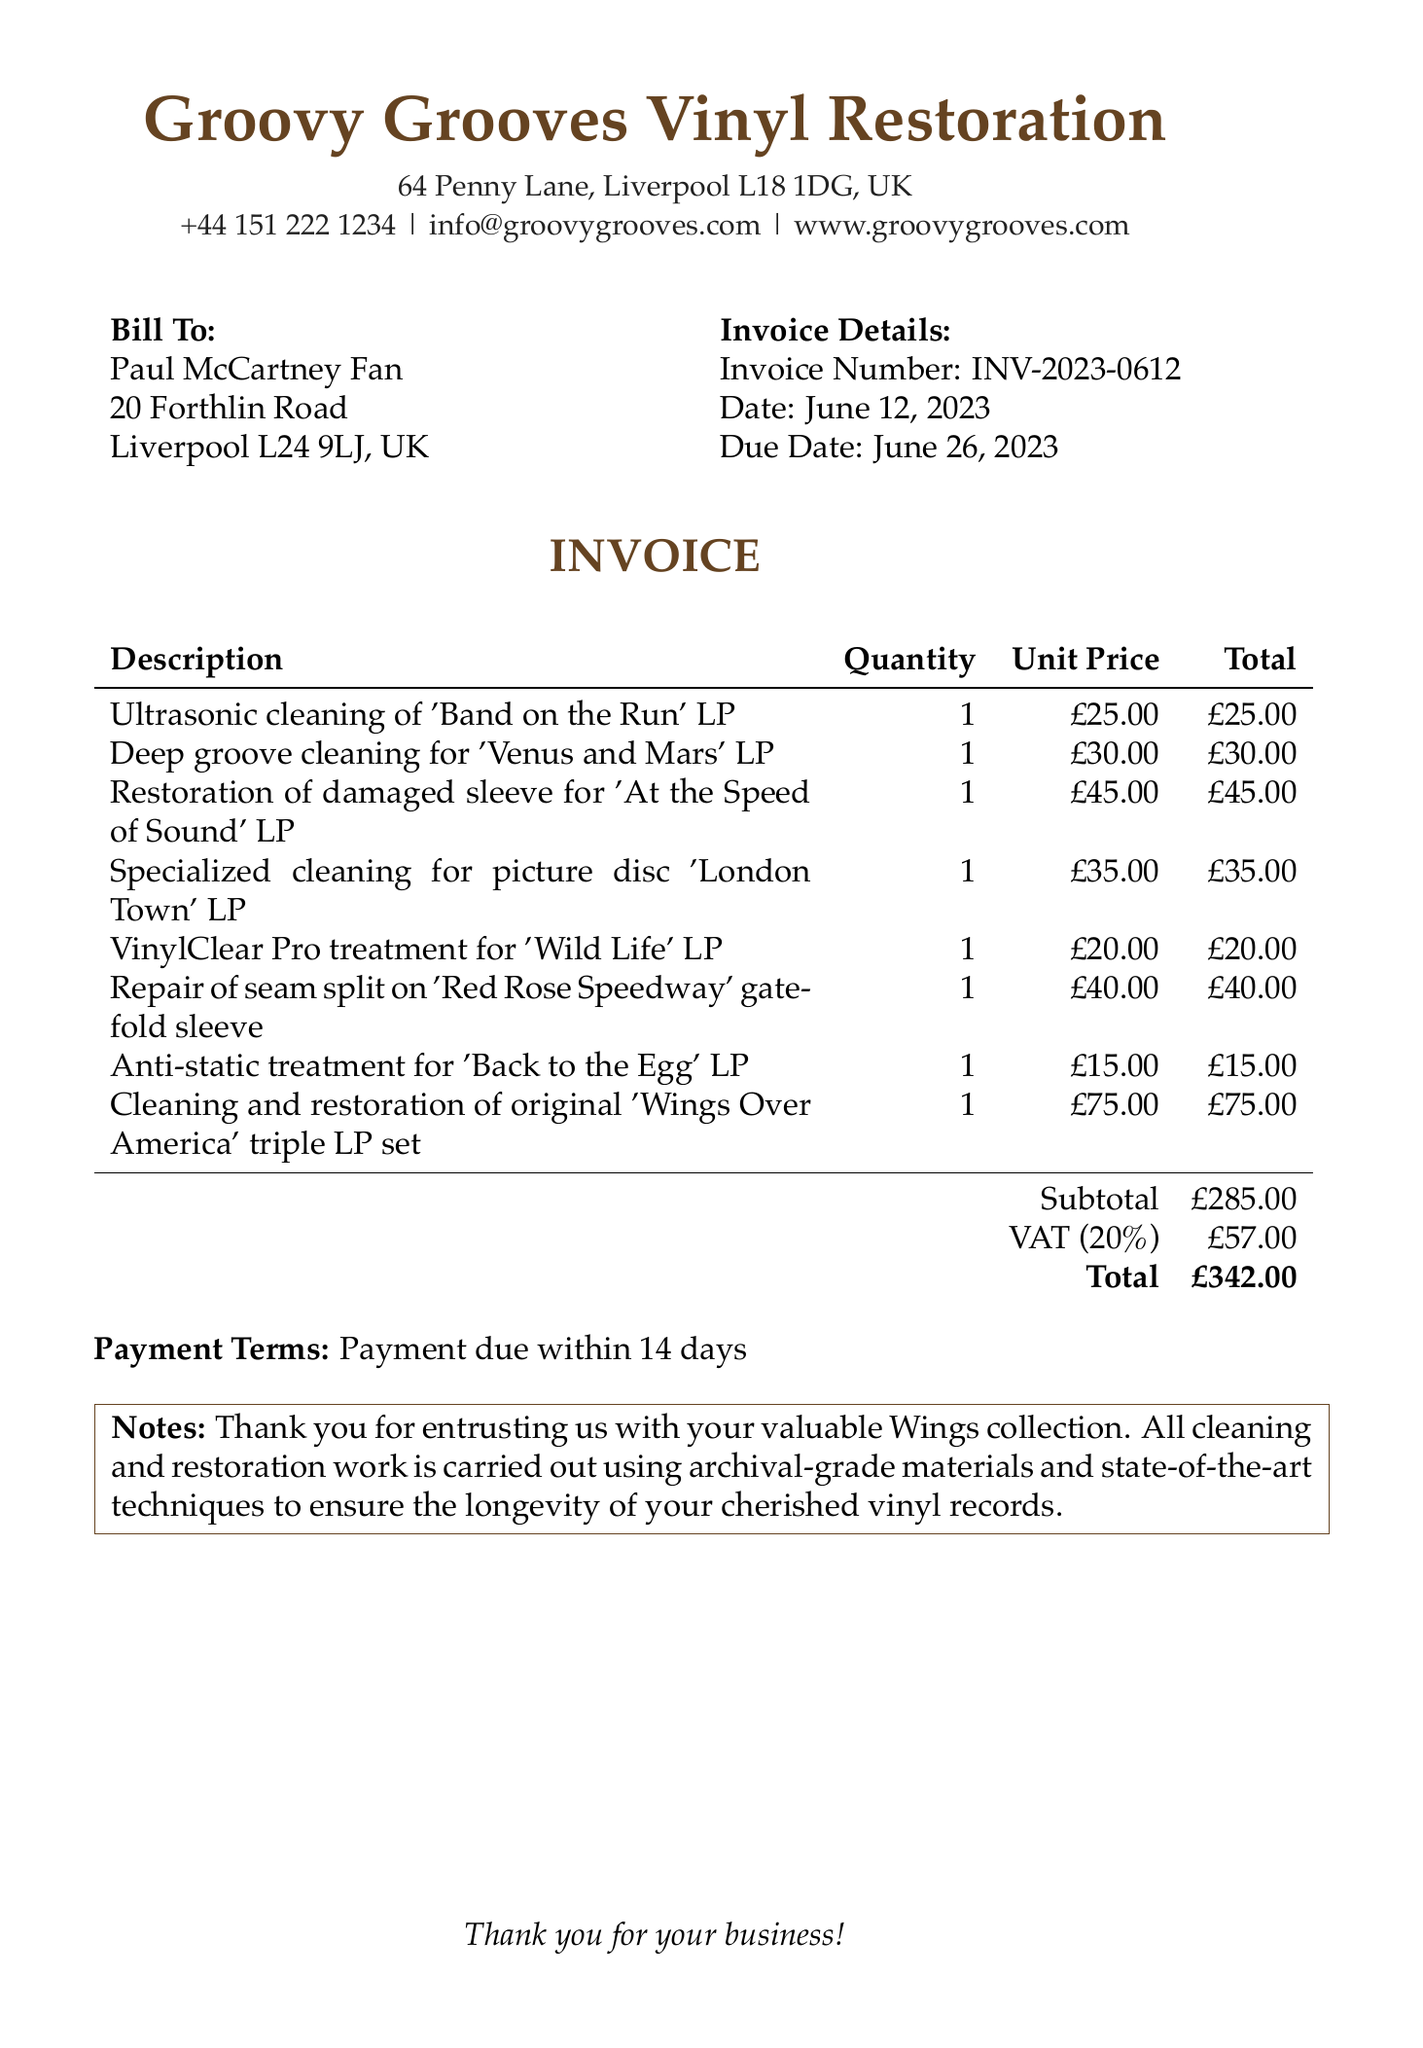What is the company name? The company name is found at the top of the invoice document.
Answer: Groovy Grooves Vinyl Restoration What is the invoice number? The invoice number is listed in the Invoice Details section.
Answer: INV-2023-0612 When is the due date? The due date can be found in the Invoice Details section.
Answer: June 26, 2023 What is the subtotal amount? The subtotal amount is listed at the bottom of the itemized services.
Answer: £285.00 How much is the tax amount? The tax amount is indicated beneath the subtotal in the invoice.
Answer: £57.00 Which LP received ultrasonic cleaning? The specific LP receiving ultrasonic cleaning can be found in the itemized list.
Answer: Band on the Run What is the total cost of the invoice? The total cost is at the very end of the invoice after the tax is added to the subtotal.
Answer: £342.00 What type of treatment was applied to 'Wild Life'? The treatment for 'Wild Life' is described in the itemized list.
Answer: VinylClear Pro treatment What is the payment term? The payment terms are stated towards the bottom of the invoice document.
Answer: Payment due within 14 days 